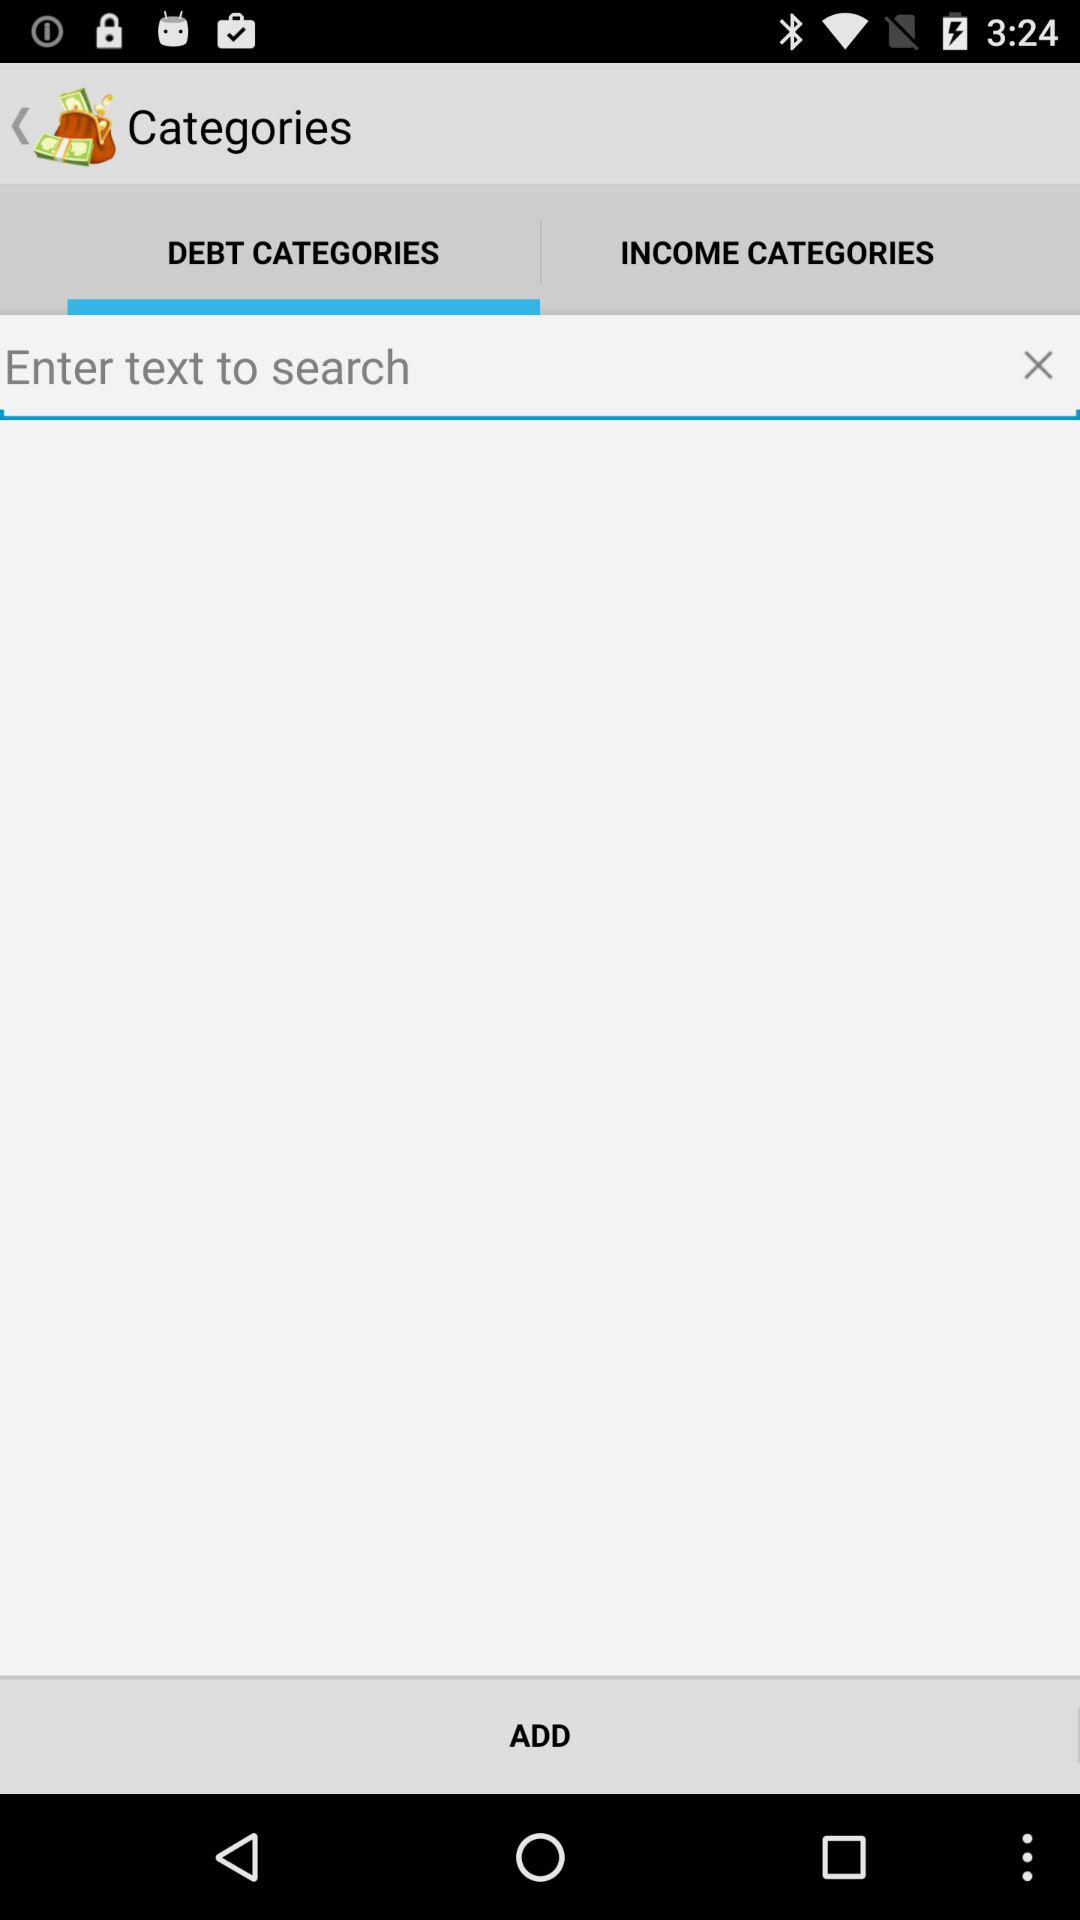Which tab is selected? The selected tab is "DEBT CATEGORIES". 